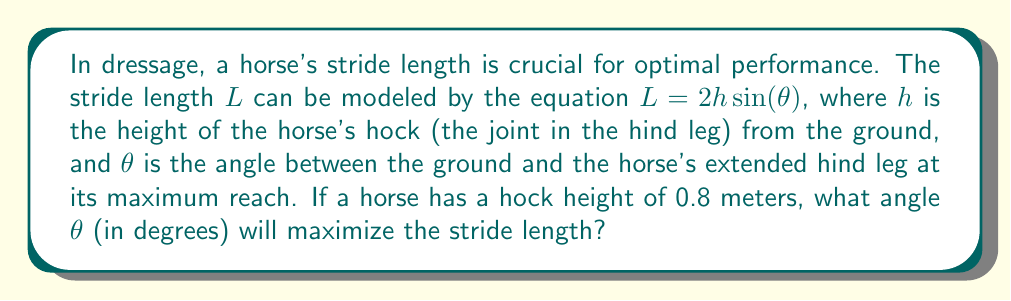Show me your answer to this math problem. To find the angle that maximizes the stride length, we need to follow these steps:

1) The equation for stride length is given as:
   $L = 2h \sin(\theta)$

2) To find the maximum value of $L$, we need to find where its derivative with respect to $\theta$ equals zero:
   $\frac{dL}{d\theta} = 2h \cos(\theta)$

3) Set this equal to zero:
   $2h \cos(\theta) = 0$

4) Solve for $\theta$:
   $\cos(\theta) = 0$
   This occurs when $\theta = 90°$ or $\frac{\pi}{2}$ radians

5) To confirm this is a maximum (not a minimum), we can check the second derivative:
   $\frac{d^2L}{d\theta^2} = -2h \sin(\theta)$
   At $\theta = 90°$, this is negative, confirming a maximum.

6) Therefore, the stride length is maximized when the angle between the ground and the horse's extended hind leg is 90°.

Note: The actual value of $h$ (0.8 meters) wasn't needed for this calculation, as the optimal angle is independent of the hock height.
Answer: 90° 